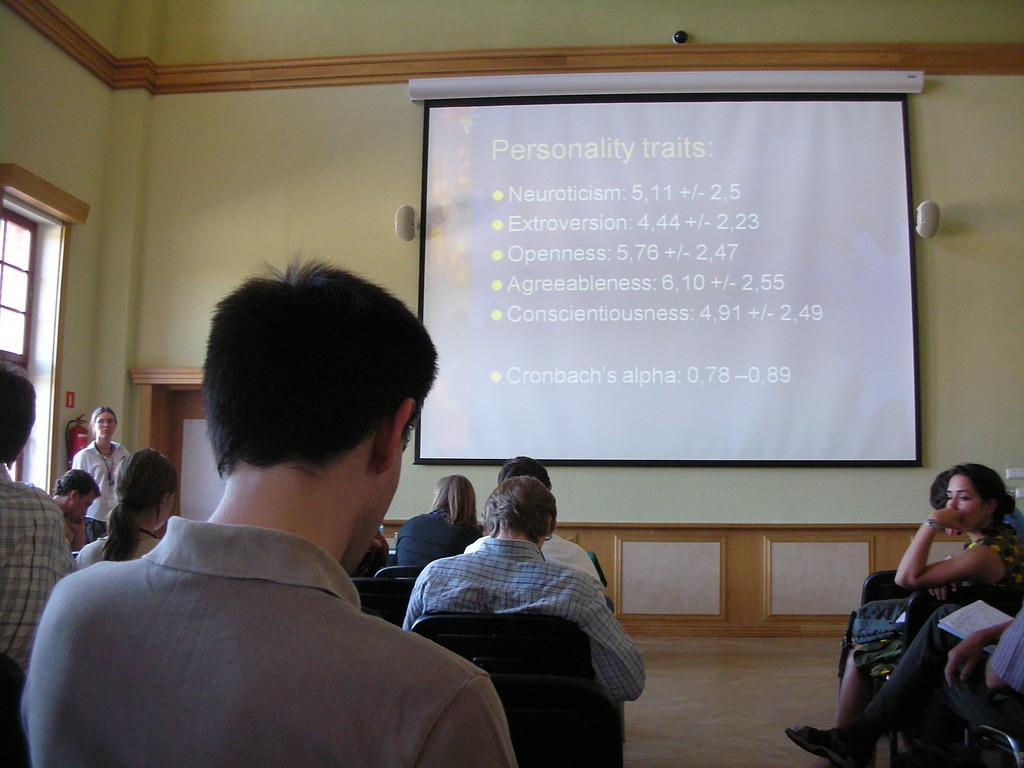Could you give a brief overview of what you see in this image? There are few people sitting on the chair on the floor. In the background there is a wall,screen,speakers,light,window and here a woman standing at the door. 